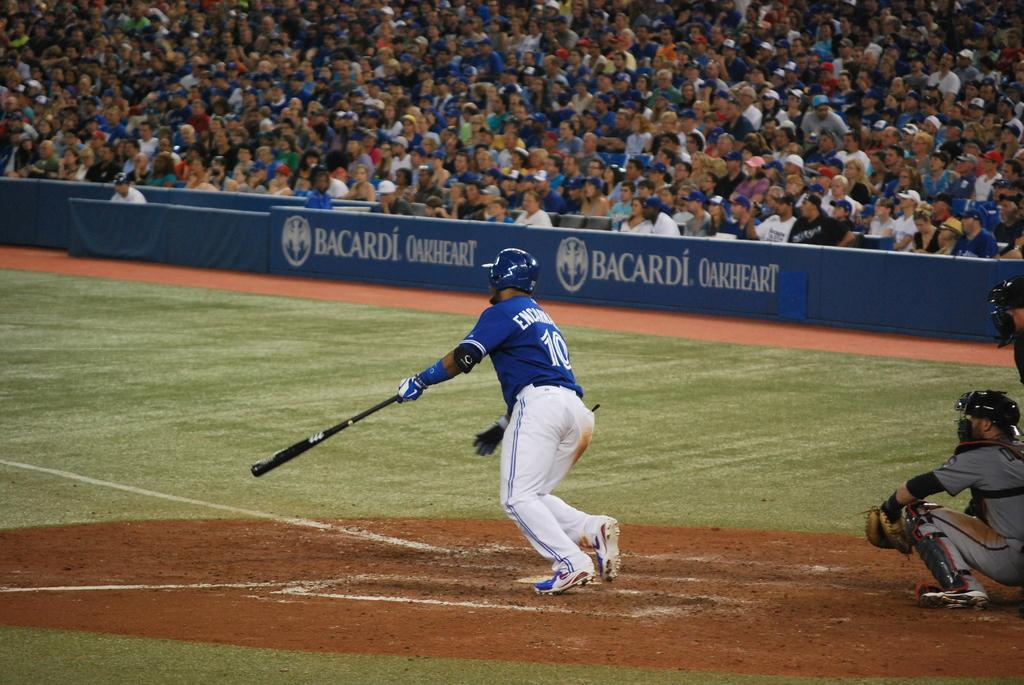<image>
Provide a brief description of the given image. a man hitting a ball with a Bacardi sign near them 